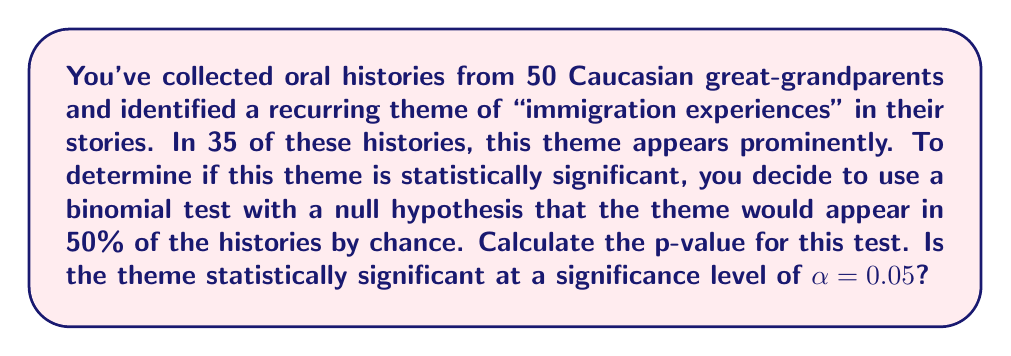Can you solve this math problem? To solve this problem, we'll use a binomial test to calculate the p-value and compare it to our significance level.

1. Define the variables:
   $n = 50$ (total number of oral histories)
   $k = 35$ (number of histories with the theme)
   $p_0 = 0.5$ (probability of the theme appearing by chance under the null hypothesis)

2. Calculate the probability of observing 35 or more successes out of 50 trials:
   
   $P(X \geq 35) = \sum_{i=35}^{50} \binom{50}{i} (0.5)^i (0.5)^{50-i}$

3. This sum can be calculated using the cumulative binomial distribution function. Most statistical software or calculators can compute this directly. Using such a tool, we find:

   $P(X \geq 35) \approx 0.0032$

4. The p-value is this probability: $p = 0.0032$

5. Compare the p-value to the significance level:
   $p = 0.0032 < \alpha = 0.05$

Since the p-value is less than the significance level, we reject the null hypothesis.
Answer: The p-value is approximately 0.0032. Since $0.0032 < 0.05$, the recurring theme of "immigration experiences" is statistically significant at the $\alpha = 0.05$ level. 